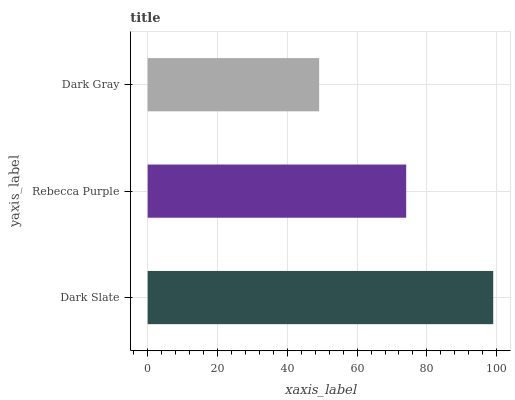Is Dark Gray the minimum?
Answer yes or no. Yes. Is Dark Slate the maximum?
Answer yes or no. Yes. Is Rebecca Purple the minimum?
Answer yes or no. No. Is Rebecca Purple the maximum?
Answer yes or no. No. Is Dark Slate greater than Rebecca Purple?
Answer yes or no. Yes. Is Rebecca Purple less than Dark Slate?
Answer yes or no. Yes. Is Rebecca Purple greater than Dark Slate?
Answer yes or no. No. Is Dark Slate less than Rebecca Purple?
Answer yes or no. No. Is Rebecca Purple the high median?
Answer yes or no. Yes. Is Rebecca Purple the low median?
Answer yes or no. Yes. Is Dark Gray the high median?
Answer yes or no. No. Is Dark Slate the low median?
Answer yes or no. No. 